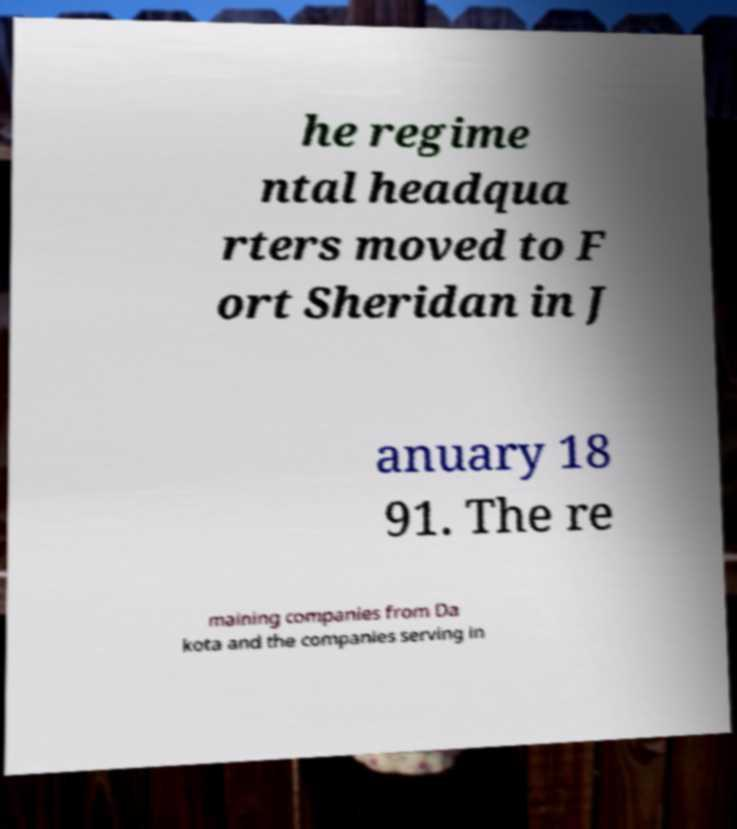Please identify and transcribe the text found in this image. he regime ntal headqua rters moved to F ort Sheridan in J anuary 18 91. The re maining companies from Da kota and the companies serving in 